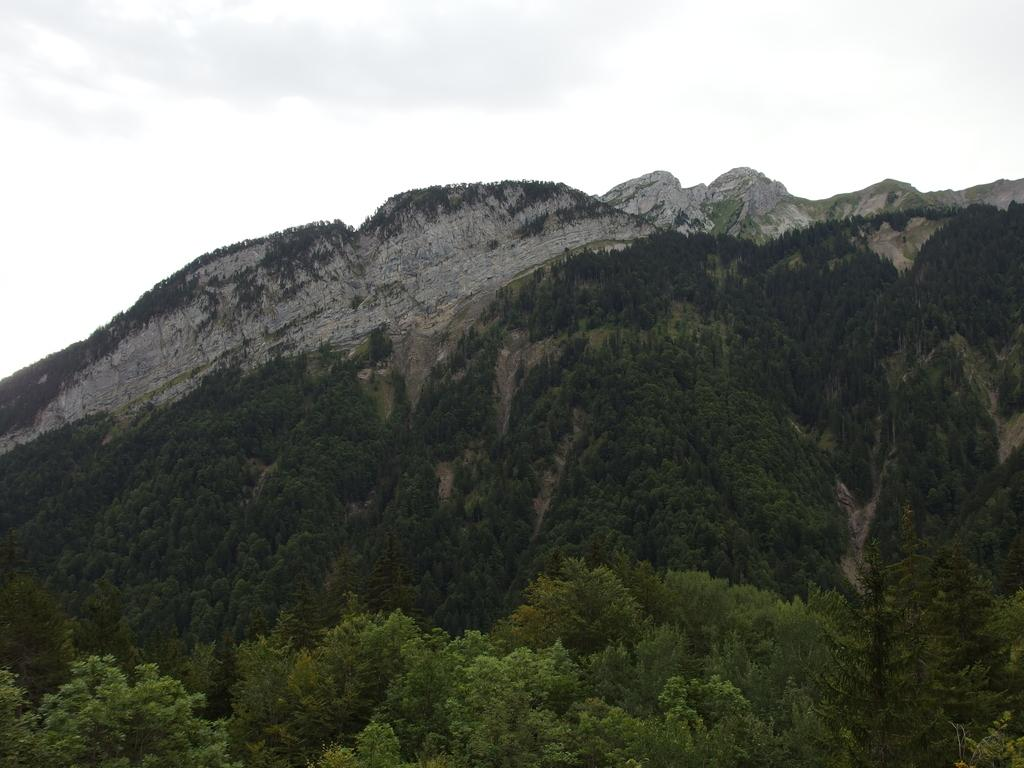What type of natural features can be seen in the image? There are trees and mountains in the image. What is the condition of the sky in the image? The sky is cloudy in the image. What type of trail can be seen in the image? There is no trail visible in the image; it only features trees, mountains, and a cloudy sky. What is the hammer used for in the image? There is no hammer present in the image. 